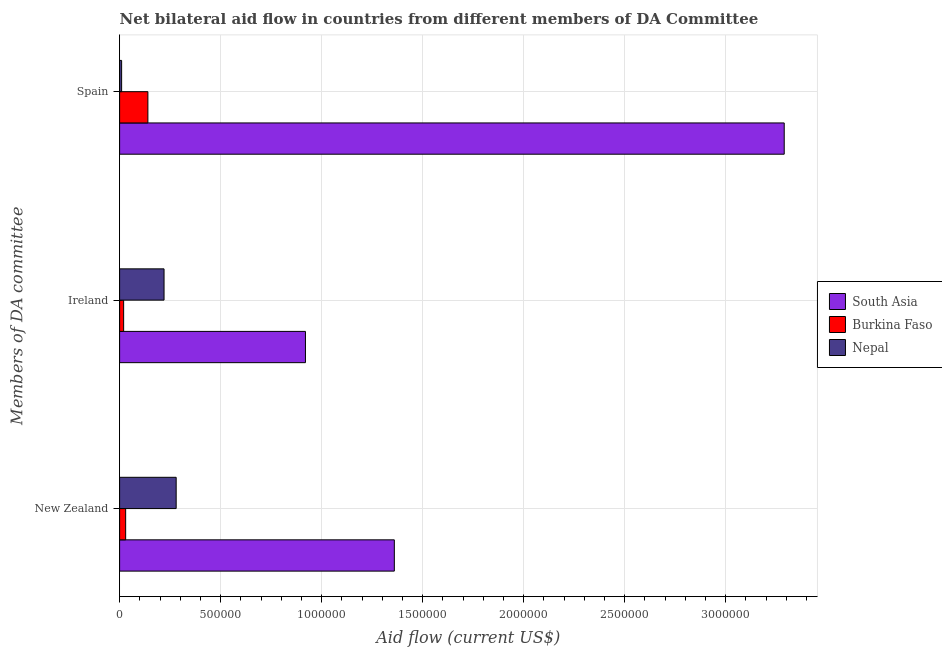How many different coloured bars are there?
Offer a very short reply. 3. How many groups of bars are there?
Give a very brief answer. 3. How many bars are there on the 1st tick from the top?
Offer a terse response. 3. What is the label of the 2nd group of bars from the top?
Provide a succinct answer. Ireland. What is the amount of aid provided by spain in South Asia?
Your response must be concise. 3.29e+06. Across all countries, what is the maximum amount of aid provided by ireland?
Keep it short and to the point. 9.20e+05. Across all countries, what is the minimum amount of aid provided by new zealand?
Your response must be concise. 3.00e+04. In which country was the amount of aid provided by ireland minimum?
Ensure brevity in your answer.  Burkina Faso. What is the total amount of aid provided by ireland in the graph?
Provide a short and direct response. 1.16e+06. What is the difference between the amount of aid provided by new zealand in Burkina Faso and that in Nepal?
Give a very brief answer. -2.50e+05. What is the difference between the amount of aid provided by new zealand in South Asia and the amount of aid provided by ireland in Nepal?
Your answer should be very brief. 1.14e+06. What is the average amount of aid provided by new zealand per country?
Your answer should be very brief. 5.57e+05. What is the difference between the amount of aid provided by ireland and amount of aid provided by new zealand in Nepal?
Make the answer very short. -6.00e+04. What is the ratio of the amount of aid provided by new zealand in Burkina Faso to that in Nepal?
Provide a short and direct response. 0.11. Is the amount of aid provided by new zealand in South Asia less than that in Burkina Faso?
Provide a short and direct response. No. Is the difference between the amount of aid provided by ireland in Nepal and Burkina Faso greater than the difference between the amount of aid provided by new zealand in Nepal and Burkina Faso?
Ensure brevity in your answer.  No. What is the difference between the highest and the second highest amount of aid provided by ireland?
Your answer should be very brief. 7.00e+05. What is the difference between the highest and the lowest amount of aid provided by spain?
Your response must be concise. 3.28e+06. In how many countries, is the amount of aid provided by new zealand greater than the average amount of aid provided by new zealand taken over all countries?
Provide a succinct answer. 1. What does the 2nd bar from the top in Spain represents?
Your answer should be compact. Burkina Faso. What does the 2nd bar from the bottom in Spain represents?
Provide a short and direct response. Burkina Faso. Is it the case that in every country, the sum of the amount of aid provided by new zealand and amount of aid provided by ireland is greater than the amount of aid provided by spain?
Make the answer very short. No. How many bars are there?
Ensure brevity in your answer.  9. Are all the bars in the graph horizontal?
Keep it short and to the point. Yes. How many countries are there in the graph?
Ensure brevity in your answer.  3. Are the values on the major ticks of X-axis written in scientific E-notation?
Provide a succinct answer. No. Does the graph contain grids?
Your response must be concise. Yes. How are the legend labels stacked?
Offer a very short reply. Vertical. What is the title of the graph?
Your answer should be very brief. Net bilateral aid flow in countries from different members of DA Committee. Does "Armenia" appear as one of the legend labels in the graph?
Offer a very short reply. No. What is the label or title of the X-axis?
Your answer should be compact. Aid flow (current US$). What is the label or title of the Y-axis?
Your response must be concise. Members of DA committee. What is the Aid flow (current US$) of South Asia in New Zealand?
Your answer should be compact. 1.36e+06. What is the Aid flow (current US$) of Burkina Faso in New Zealand?
Your response must be concise. 3.00e+04. What is the Aid flow (current US$) of Nepal in New Zealand?
Give a very brief answer. 2.80e+05. What is the Aid flow (current US$) of South Asia in Ireland?
Your answer should be compact. 9.20e+05. What is the Aid flow (current US$) in Nepal in Ireland?
Offer a terse response. 2.20e+05. What is the Aid flow (current US$) in South Asia in Spain?
Offer a very short reply. 3.29e+06. Across all Members of DA committee, what is the maximum Aid flow (current US$) in South Asia?
Offer a terse response. 3.29e+06. Across all Members of DA committee, what is the maximum Aid flow (current US$) of Burkina Faso?
Your answer should be very brief. 1.40e+05. Across all Members of DA committee, what is the minimum Aid flow (current US$) of South Asia?
Make the answer very short. 9.20e+05. Across all Members of DA committee, what is the minimum Aid flow (current US$) of Nepal?
Your answer should be very brief. 10000. What is the total Aid flow (current US$) of South Asia in the graph?
Keep it short and to the point. 5.57e+06. What is the total Aid flow (current US$) of Burkina Faso in the graph?
Provide a succinct answer. 1.90e+05. What is the total Aid flow (current US$) of Nepal in the graph?
Your answer should be very brief. 5.10e+05. What is the difference between the Aid flow (current US$) in South Asia in New Zealand and that in Ireland?
Provide a succinct answer. 4.40e+05. What is the difference between the Aid flow (current US$) in South Asia in New Zealand and that in Spain?
Provide a succinct answer. -1.93e+06. What is the difference between the Aid flow (current US$) in Burkina Faso in New Zealand and that in Spain?
Ensure brevity in your answer.  -1.10e+05. What is the difference between the Aid flow (current US$) of Nepal in New Zealand and that in Spain?
Your response must be concise. 2.70e+05. What is the difference between the Aid flow (current US$) in South Asia in Ireland and that in Spain?
Your response must be concise. -2.37e+06. What is the difference between the Aid flow (current US$) in Nepal in Ireland and that in Spain?
Provide a short and direct response. 2.10e+05. What is the difference between the Aid flow (current US$) of South Asia in New Zealand and the Aid flow (current US$) of Burkina Faso in Ireland?
Offer a terse response. 1.34e+06. What is the difference between the Aid flow (current US$) of South Asia in New Zealand and the Aid flow (current US$) of Nepal in Ireland?
Provide a short and direct response. 1.14e+06. What is the difference between the Aid flow (current US$) in South Asia in New Zealand and the Aid flow (current US$) in Burkina Faso in Spain?
Ensure brevity in your answer.  1.22e+06. What is the difference between the Aid flow (current US$) of South Asia in New Zealand and the Aid flow (current US$) of Nepal in Spain?
Ensure brevity in your answer.  1.35e+06. What is the difference between the Aid flow (current US$) of Burkina Faso in New Zealand and the Aid flow (current US$) of Nepal in Spain?
Provide a short and direct response. 2.00e+04. What is the difference between the Aid flow (current US$) in South Asia in Ireland and the Aid flow (current US$) in Burkina Faso in Spain?
Your answer should be compact. 7.80e+05. What is the difference between the Aid flow (current US$) in South Asia in Ireland and the Aid flow (current US$) in Nepal in Spain?
Keep it short and to the point. 9.10e+05. What is the difference between the Aid flow (current US$) in Burkina Faso in Ireland and the Aid flow (current US$) in Nepal in Spain?
Your answer should be compact. 10000. What is the average Aid flow (current US$) of South Asia per Members of DA committee?
Make the answer very short. 1.86e+06. What is the average Aid flow (current US$) of Burkina Faso per Members of DA committee?
Keep it short and to the point. 6.33e+04. What is the average Aid flow (current US$) of Nepal per Members of DA committee?
Make the answer very short. 1.70e+05. What is the difference between the Aid flow (current US$) in South Asia and Aid flow (current US$) in Burkina Faso in New Zealand?
Offer a very short reply. 1.33e+06. What is the difference between the Aid flow (current US$) in South Asia and Aid flow (current US$) in Nepal in New Zealand?
Keep it short and to the point. 1.08e+06. What is the difference between the Aid flow (current US$) in Burkina Faso and Aid flow (current US$) in Nepal in New Zealand?
Offer a very short reply. -2.50e+05. What is the difference between the Aid flow (current US$) of South Asia and Aid flow (current US$) of Nepal in Ireland?
Your answer should be very brief. 7.00e+05. What is the difference between the Aid flow (current US$) in Burkina Faso and Aid flow (current US$) in Nepal in Ireland?
Your answer should be very brief. -2.00e+05. What is the difference between the Aid flow (current US$) in South Asia and Aid flow (current US$) in Burkina Faso in Spain?
Provide a short and direct response. 3.15e+06. What is the difference between the Aid flow (current US$) in South Asia and Aid flow (current US$) in Nepal in Spain?
Provide a short and direct response. 3.28e+06. What is the difference between the Aid flow (current US$) in Burkina Faso and Aid flow (current US$) in Nepal in Spain?
Keep it short and to the point. 1.30e+05. What is the ratio of the Aid flow (current US$) of South Asia in New Zealand to that in Ireland?
Make the answer very short. 1.48. What is the ratio of the Aid flow (current US$) of Burkina Faso in New Zealand to that in Ireland?
Ensure brevity in your answer.  1.5. What is the ratio of the Aid flow (current US$) in Nepal in New Zealand to that in Ireland?
Make the answer very short. 1.27. What is the ratio of the Aid flow (current US$) in South Asia in New Zealand to that in Spain?
Keep it short and to the point. 0.41. What is the ratio of the Aid flow (current US$) in Burkina Faso in New Zealand to that in Spain?
Your response must be concise. 0.21. What is the ratio of the Aid flow (current US$) of Nepal in New Zealand to that in Spain?
Your answer should be very brief. 28. What is the ratio of the Aid flow (current US$) in South Asia in Ireland to that in Spain?
Offer a very short reply. 0.28. What is the ratio of the Aid flow (current US$) in Burkina Faso in Ireland to that in Spain?
Your answer should be compact. 0.14. What is the ratio of the Aid flow (current US$) of Nepal in Ireland to that in Spain?
Give a very brief answer. 22. What is the difference between the highest and the second highest Aid flow (current US$) in South Asia?
Provide a short and direct response. 1.93e+06. What is the difference between the highest and the second highest Aid flow (current US$) in Burkina Faso?
Ensure brevity in your answer.  1.10e+05. What is the difference between the highest and the second highest Aid flow (current US$) in Nepal?
Provide a short and direct response. 6.00e+04. What is the difference between the highest and the lowest Aid flow (current US$) of South Asia?
Make the answer very short. 2.37e+06. What is the difference between the highest and the lowest Aid flow (current US$) of Burkina Faso?
Keep it short and to the point. 1.20e+05. 